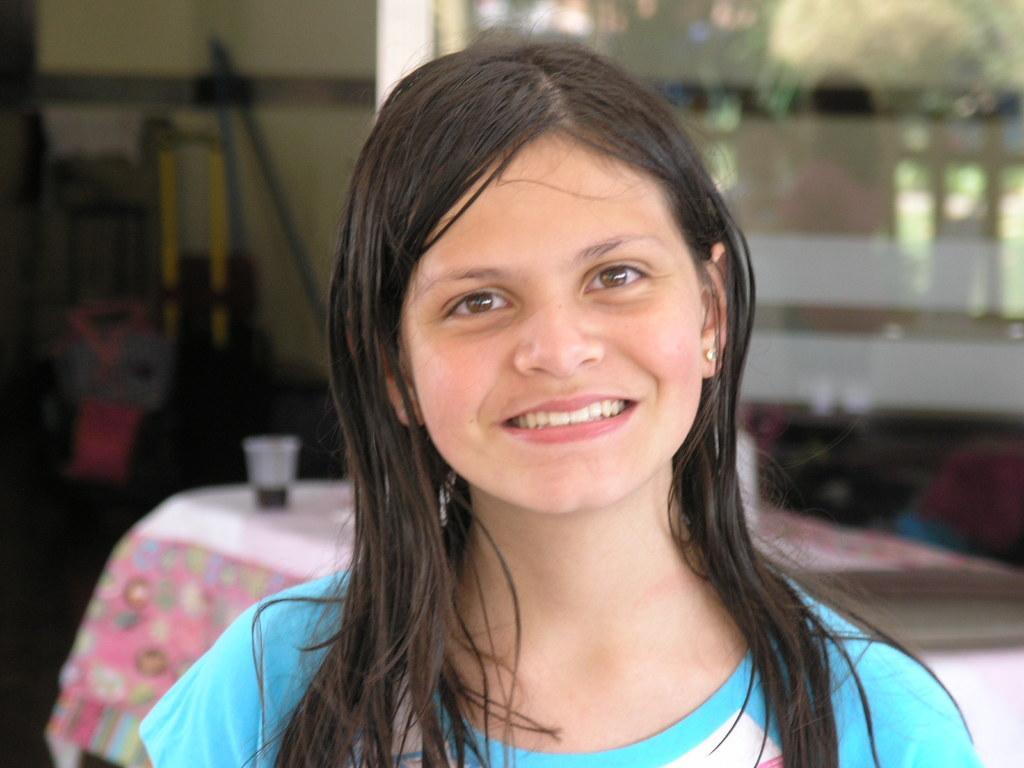How would you summarize this image in a sentence or two? In this image, we can see a woman is watching and smiling. Background there is a blur view. Here there is a table covered with cloth. On top of that there are few items are placed on it. Here we can see glass object. On the glass we can see few reflections. On the left side of the image, we can see few objects. 